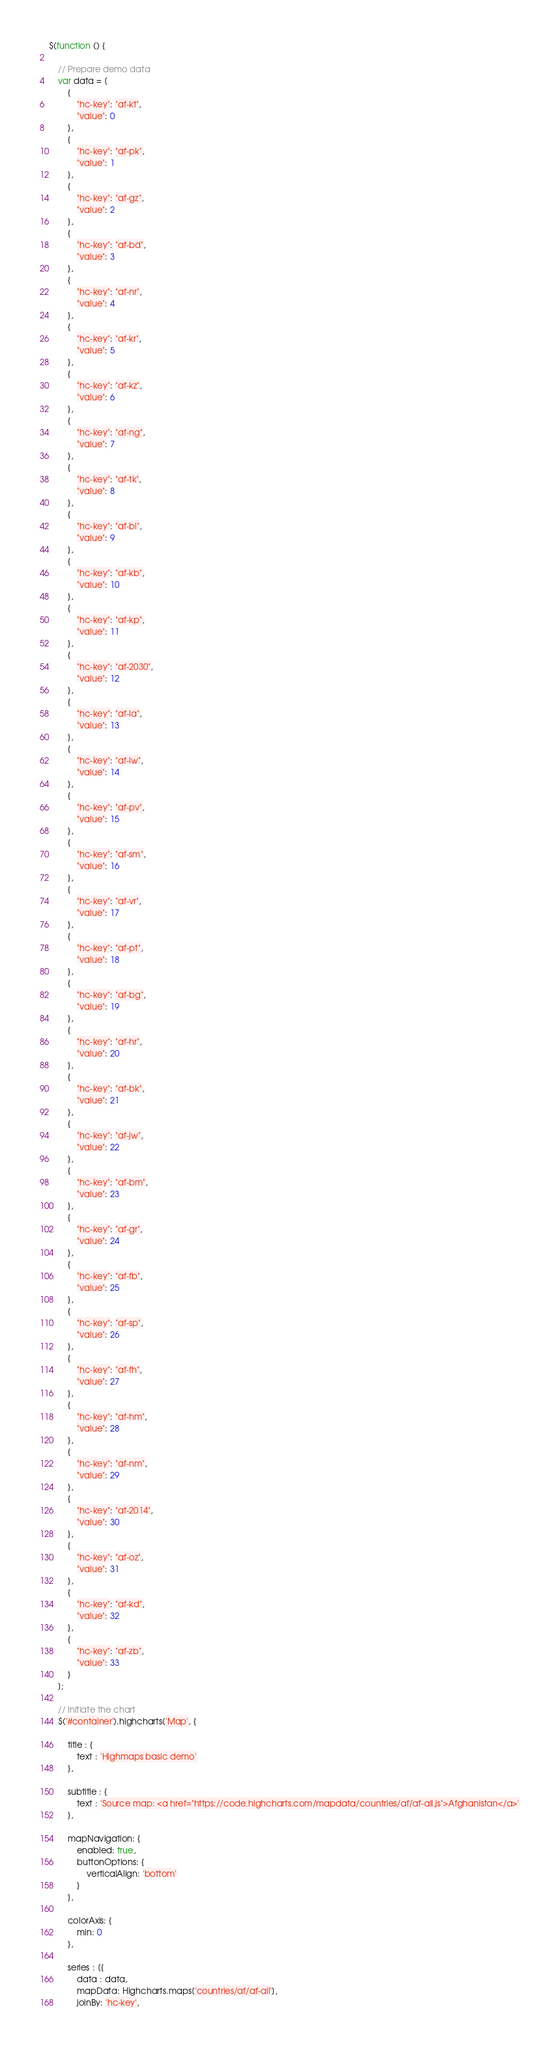<code> <loc_0><loc_0><loc_500><loc_500><_JavaScript_>$(function () {

    // Prepare demo data
    var data = [
        {
            "hc-key": "af-kt",
            "value": 0
        },
        {
            "hc-key": "af-pk",
            "value": 1
        },
        {
            "hc-key": "af-gz",
            "value": 2
        },
        {
            "hc-key": "af-bd",
            "value": 3
        },
        {
            "hc-key": "af-nr",
            "value": 4
        },
        {
            "hc-key": "af-kr",
            "value": 5
        },
        {
            "hc-key": "af-kz",
            "value": 6
        },
        {
            "hc-key": "af-ng",
            "value": 7
        },
        {
            "hc-key": "af-tk",
            "value": 8
        },
        {
            "hc-key": "af-bl",
            "value": 9
        },
        {
            "hc-key": "af-kb",
            "value": 10
        },
        {
            "hc-key": "af-kp",
            "value": 11
        },
        {
            "hc-key": "af-2030",
            "value": 12
        },
        {
            "hc-key": "af-la",
            "value": 13
        },
        {
            "hc-key": "af-lw",
            "value": 14
        },
        {
            "hc-key": "af-pv",
            "value": 15
        },
        {
            "hc-key": "af-sm",
            "value": 16
        },
        {
            "hc-key": "af-vr",
            "value": 17
        },
        {
            "hc-key": "af-pt",
            "value": 18
        },
        {
            "hc-key": "af-bg",
            "value": 19
        },
        {
            "hc-key": "af-hr",
            "value": 20
        },
        {
            "hc-key": "af-bk",
            "value": 21
        },
        {
            "hc-key": "af-jw",
            "value": 22
        },
        {
            "hc-key": "af-bm",
            "value": 23
        },
        {
            "hc-key": "af-gr",
            "value": 24
        },
        {
            "hc-key": "af-fb",
            "value": 25
        },
        {
            "hc-key": "af-sp",
            "value": 26
        },
        {
            "hc-key": "af-fh",
            "value": 27
        },
        {
            "hc-key": "af-hm",
            "value": 28
        },
        {
            "hc-key": "af-nm",
            "value": 29
        },
        {
            "hc-key": "af-2014",
            "value": 30
        },
        {
            "hc-key": "af-oz",
            "value": 31
        },
        {
            "hc-key": "af-kd",
            "value": 32
        },
        {
            "hc-key": "af-zb",
            "value": 33
        }
    ];

    // Initiate the chart
    $('#container').highcharts('Map', {

        title : {
            text : 'Highmaps basic demo'
        },

        subtitle : {
            text : 'Source map: <a href="https://code.highcharts.com/mapdata/countries/af/af-all.js">Afghanistan</a>'
        },

        mapNavigation: {
            enabled: true,
            buttonOptions: {
                verticalAlign: 'bottom'
            }
        },

        colorAxis: {
            min: 0
        },

        series : [{
            data : data,
            mapData: Highcharts.maps['countries/af/af-all'],
            joinBy: 'hc-key',</code> 